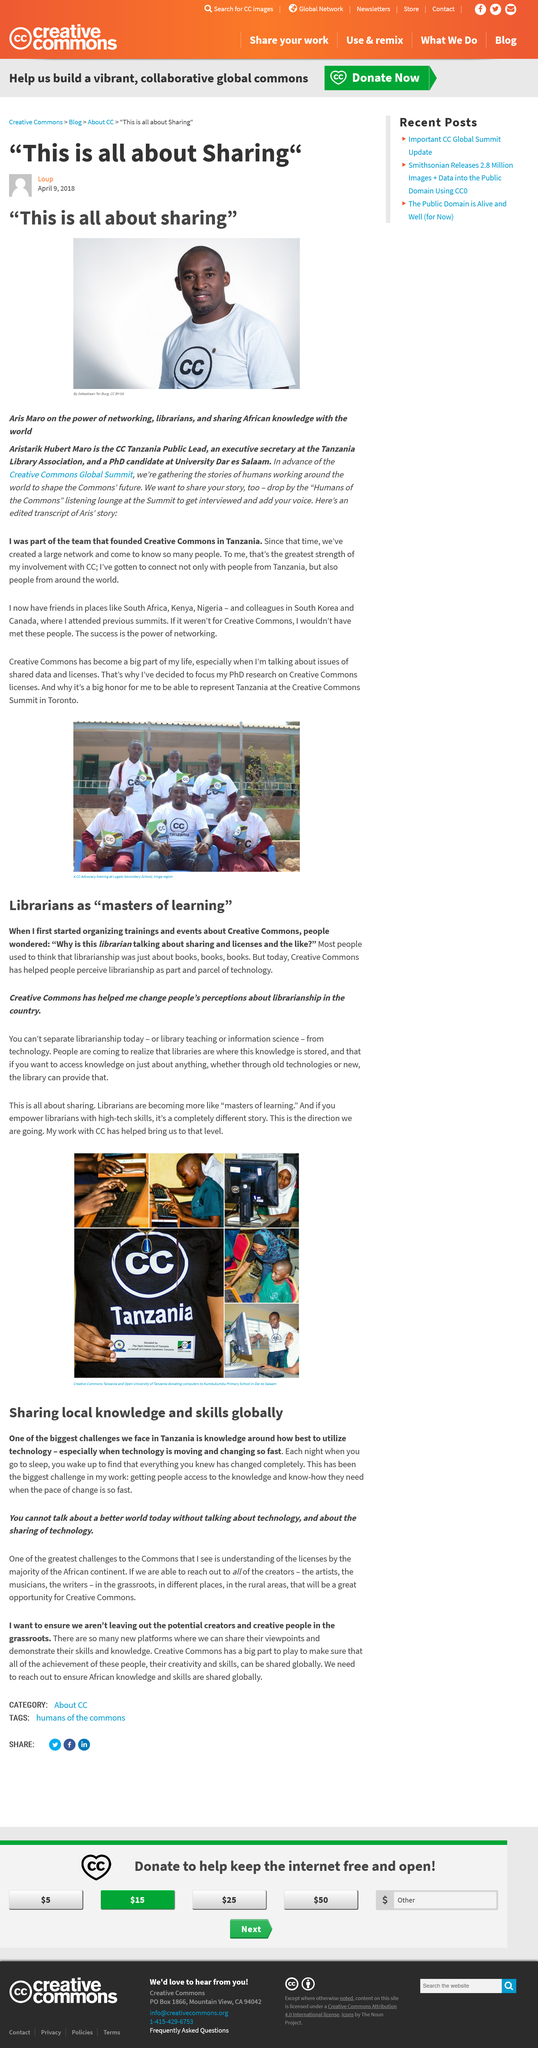Mention a couple of crucial points in this snapshot. The biggest challenge faced by people is getting access to the knowledge and know-how they need. It is explicitly stated that anyone can be interviewed at the "Humans of the commons" listening lounge at the Summit, as specified by the author in the text. Aris Maro, a citizen of Tanzania, is from that Afrikan country. Technology is not moving at a slow pace; instead, it changes rapidly. The speaker is mentioning that they are referring to the 2018 CC Global Summit. 